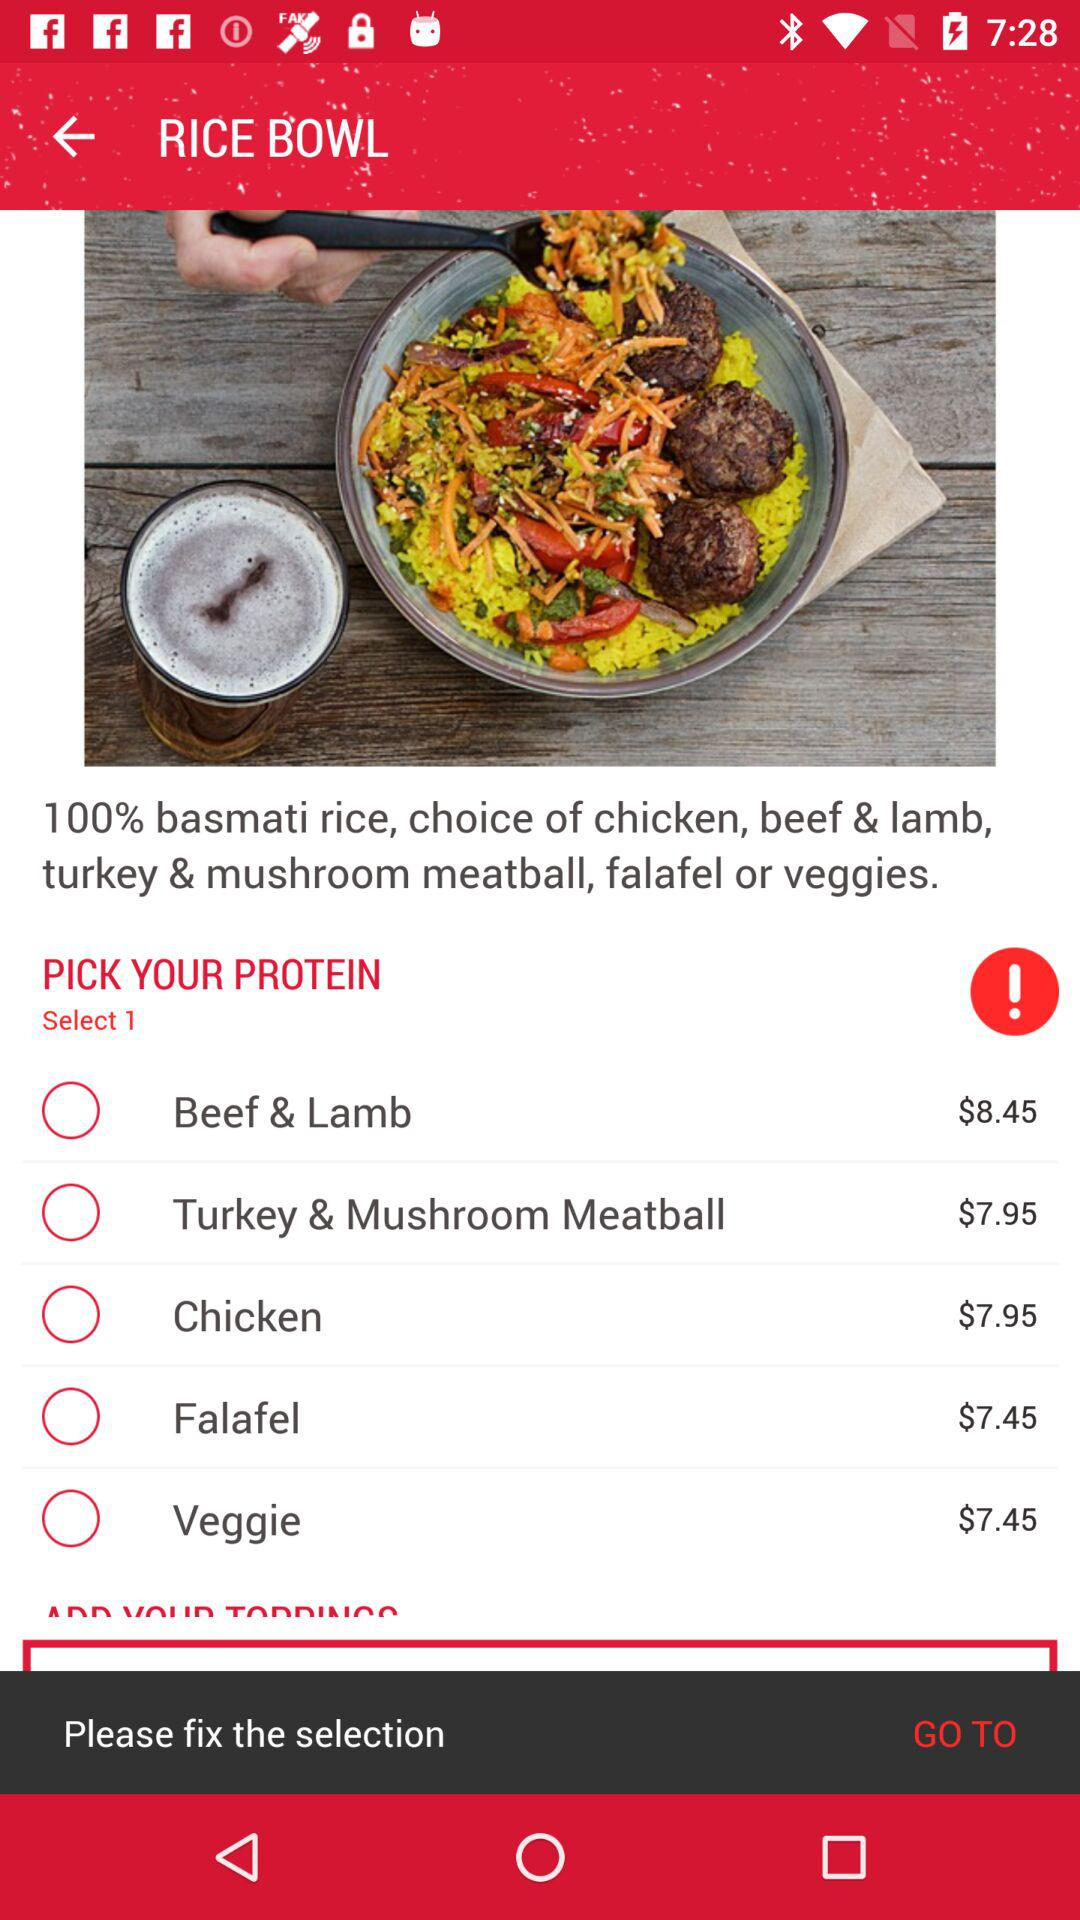What is the application name?
When the provided information is insufficient, respond with <no answer>. <no answer> 